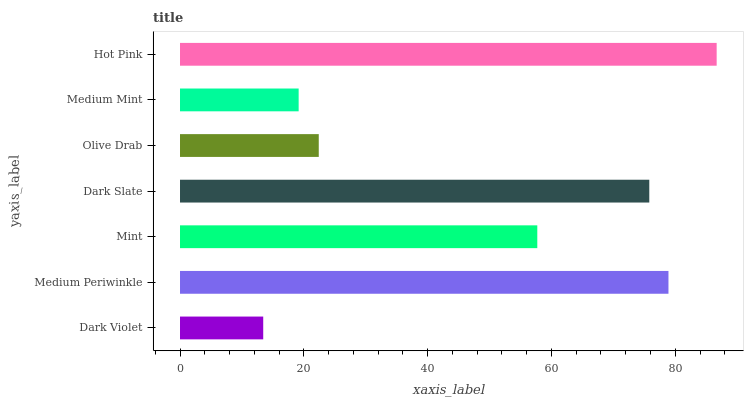Is Dark Violet the minimum?
Answer yes or no. Yes. Is Hot Pink the maximum?
Answer yes or no. Yes. Is Medium Periwinkle the minimum?
Answer yes or no. No. Is Medium Periwinkle the maximum?
Answer yes or no. No. Is Medium Periwinkle greater than Dark Violet?
Answer yes or no. Yes. Is Dark Violet less than Medium Periwinkle?
Answer yes or no. Yes. Is Dark Violet greater than Medium Periwinkle?
Answer yes or no. No. Is Medium Periwinkle less than Dark Violet?
Answer yes or no. No. Is Mint the high median?
Answer yes or no. Yes. Is Mint the low median?
Answer yes or no. Yes. Is Dark Slate the high median?
Answer yes or no. No. Is Dark Violet the low median?
Answer yes or no. No. 